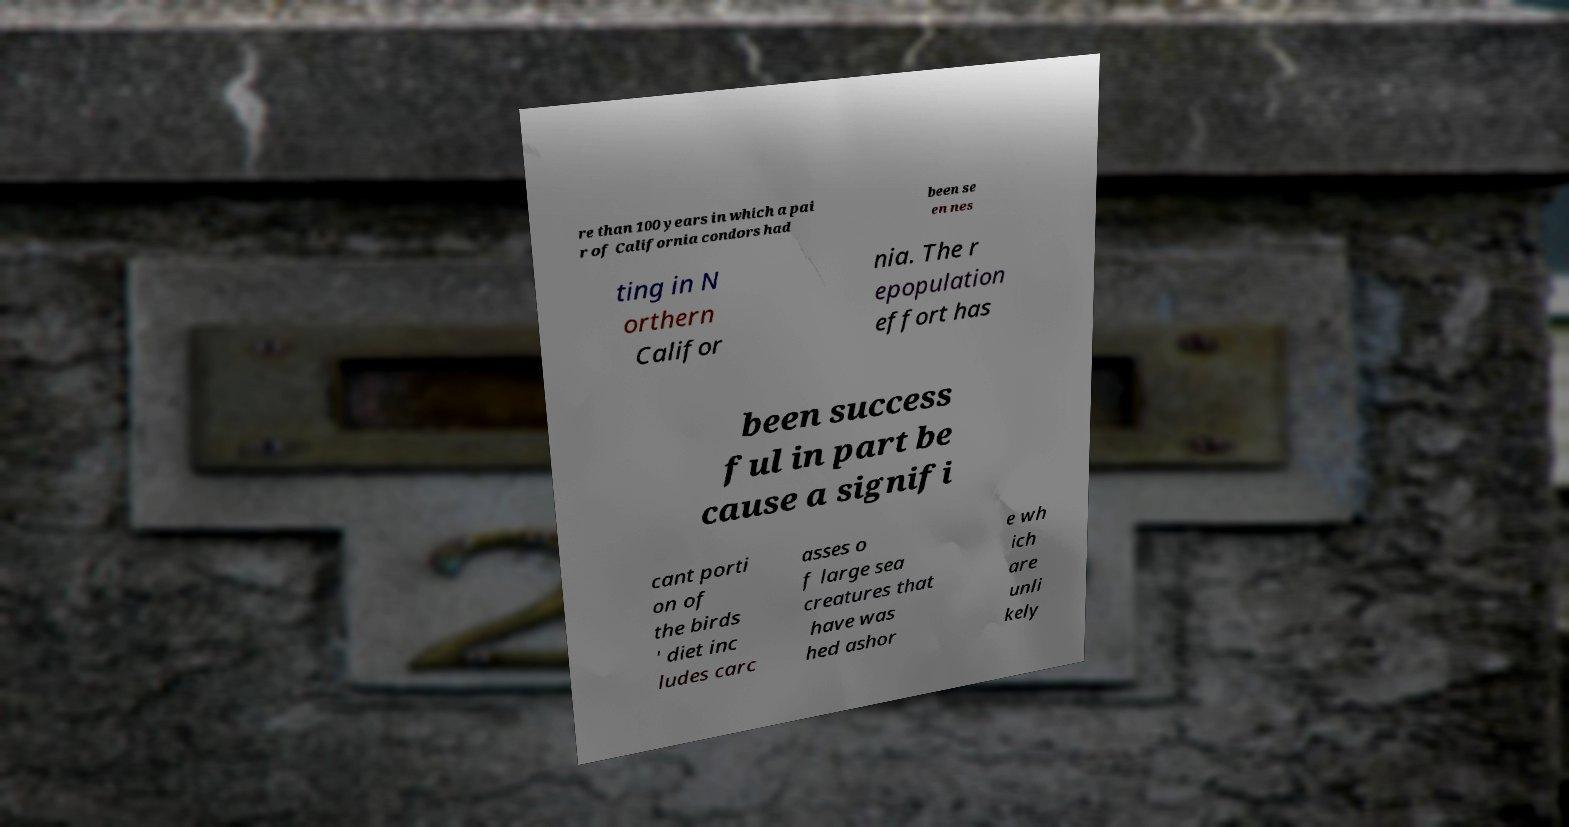Please identify and transcribe the text found in this image. re than 100 years in which a pai r of California condors had been se en nes ting in N orthern Califor nia. The r epopulation effort has been success ful in part be cause a signifi cant porti on of the birds ' diet inc ludes carc asses o f large sea creatures that have was hed ashor e wh ich are unli kely 